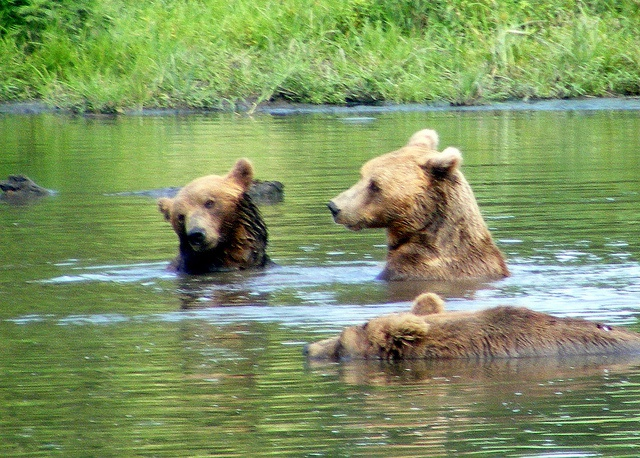Describe the objects in this image and their specific colors. I can see bear in darkgreen, tan, and gray tones, bear in darkgreen, gray, tan, and darkgray tones, and bear in darkgreen, black, tan, and gray tones in this image. 